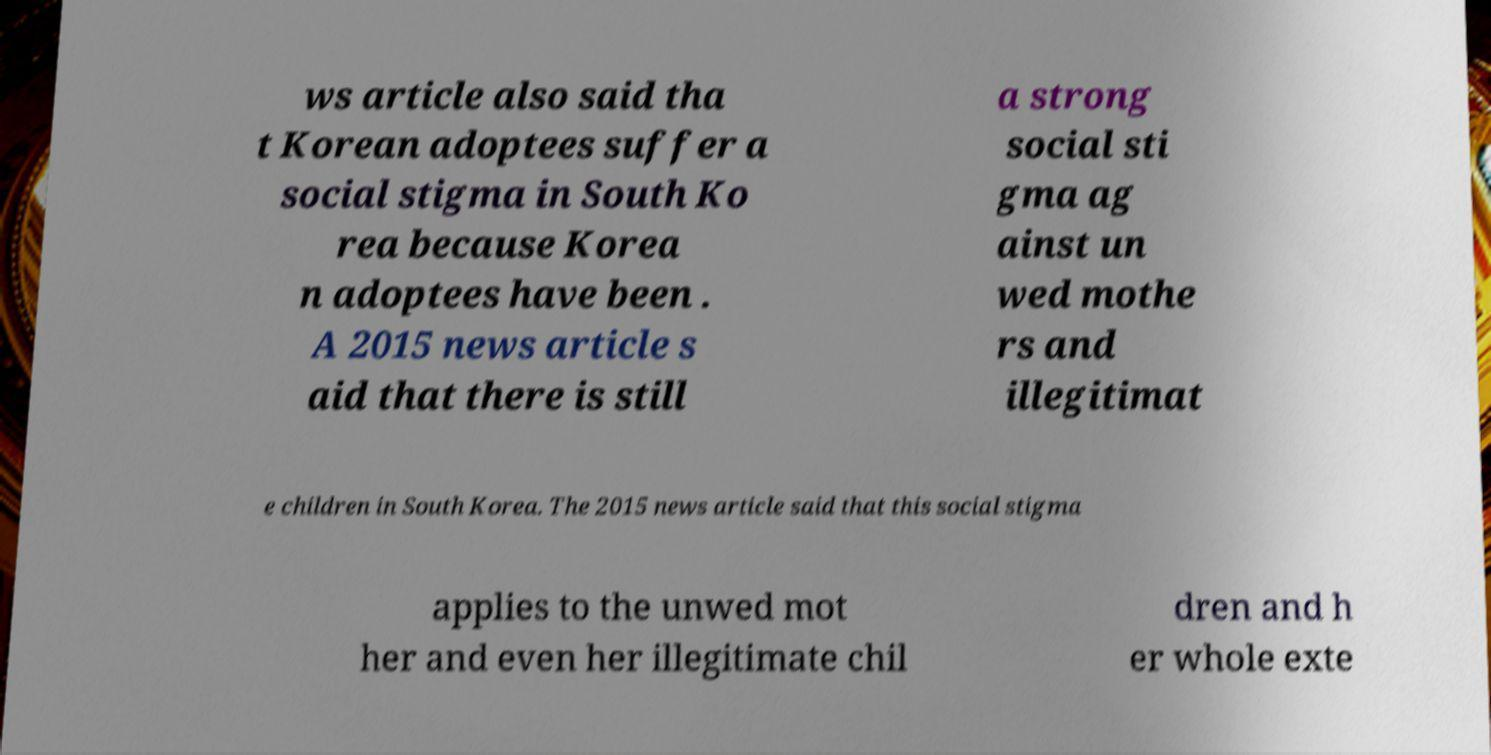For documentation purposes, I need the text within this image transcribed. Could you provide that? ws article also said tha t Korean adoptees suffer a social stigma in South Ko rea because Korea n adoptees have been . A 2015 news article s aid that there is still a strong social sti gma ag ainst un wed mothe rs and illegitimat e children in South Korea. The 2015 news article said that this social stigma applies to the unwed mot her and even her illegitimate chil dren and h er whole exte 